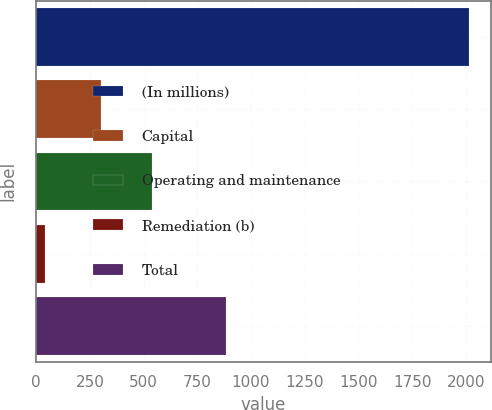<chart> <loc_0><loc_0><loc_500><loc_500><bar_chart><fcel>(In millions)<fcel>Capital<fcel>Operating and maintenance<fcel>Remediation (b)<fcel>Total<nl><fcel>2016<fcel>302<fcel>541<fcel>40<fcel>883<nl></chart> 